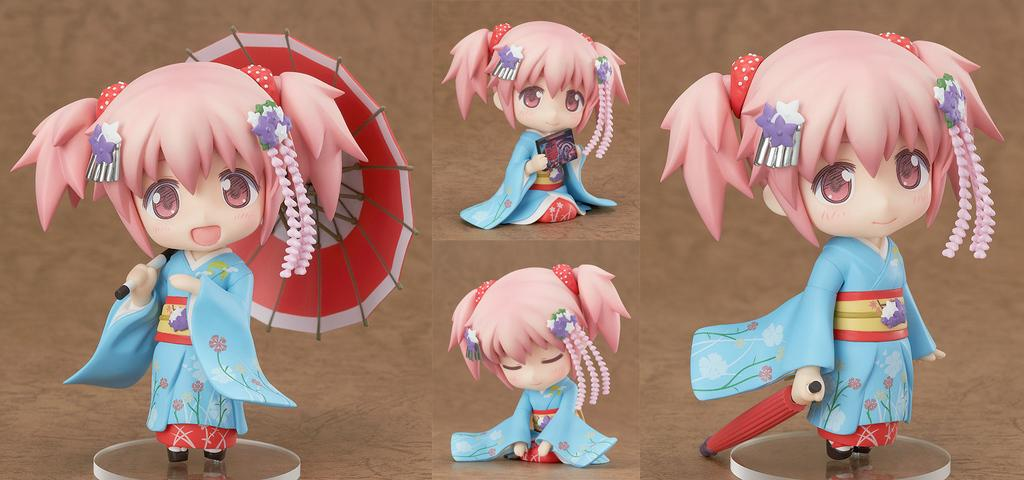How many doll images are present in the picture? There are four images of a doll in the picture. What is the doll wearing in the images? The doll is wearing a blue dress in the images. How does the doll's posture vary in the different images? The doll has different postures in each image. What is the color of the background in the picture? The background color is brown. How much does the doll weigh in the image? The weight of the doll cannot be determined from the image, as it does not provide information about the doll's mass. 